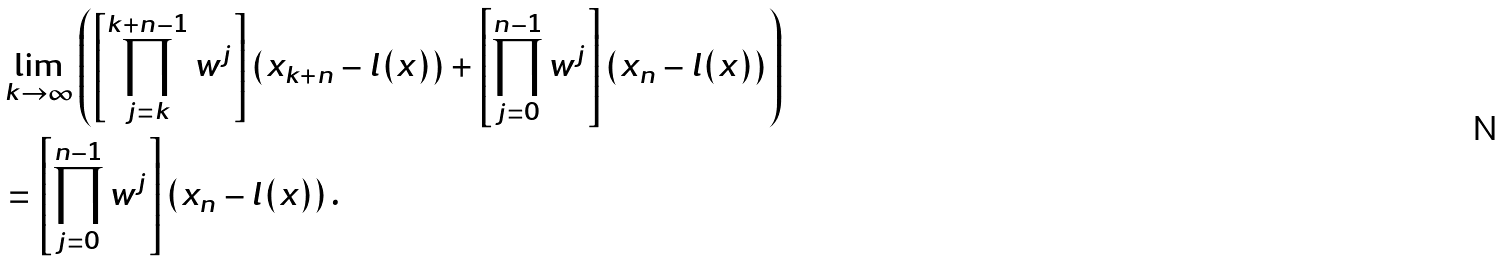Convert formula to latex. <formula><loc_0><loc_0><loc_500><loc_500>& \lim _ { k \to \infty } \left ( \left [ \prod _ { j = k } ^ { k + n - 1 } w ^ { j } \right ] \left ( x _ { k + n } - l ( x ) \right ) + \left [ \prod _ { j = 0 } ^ { n - 1 } w ^ { j } \right ] \left ( x _ { n } - l ( x ) \right ) \right ) \\ & = \left [ \prod _ { j = 0 } ^ { n - 1 } w ^ { j } \right ] \left ( x _ { n } - l ( x ) \right ) .</formula> 